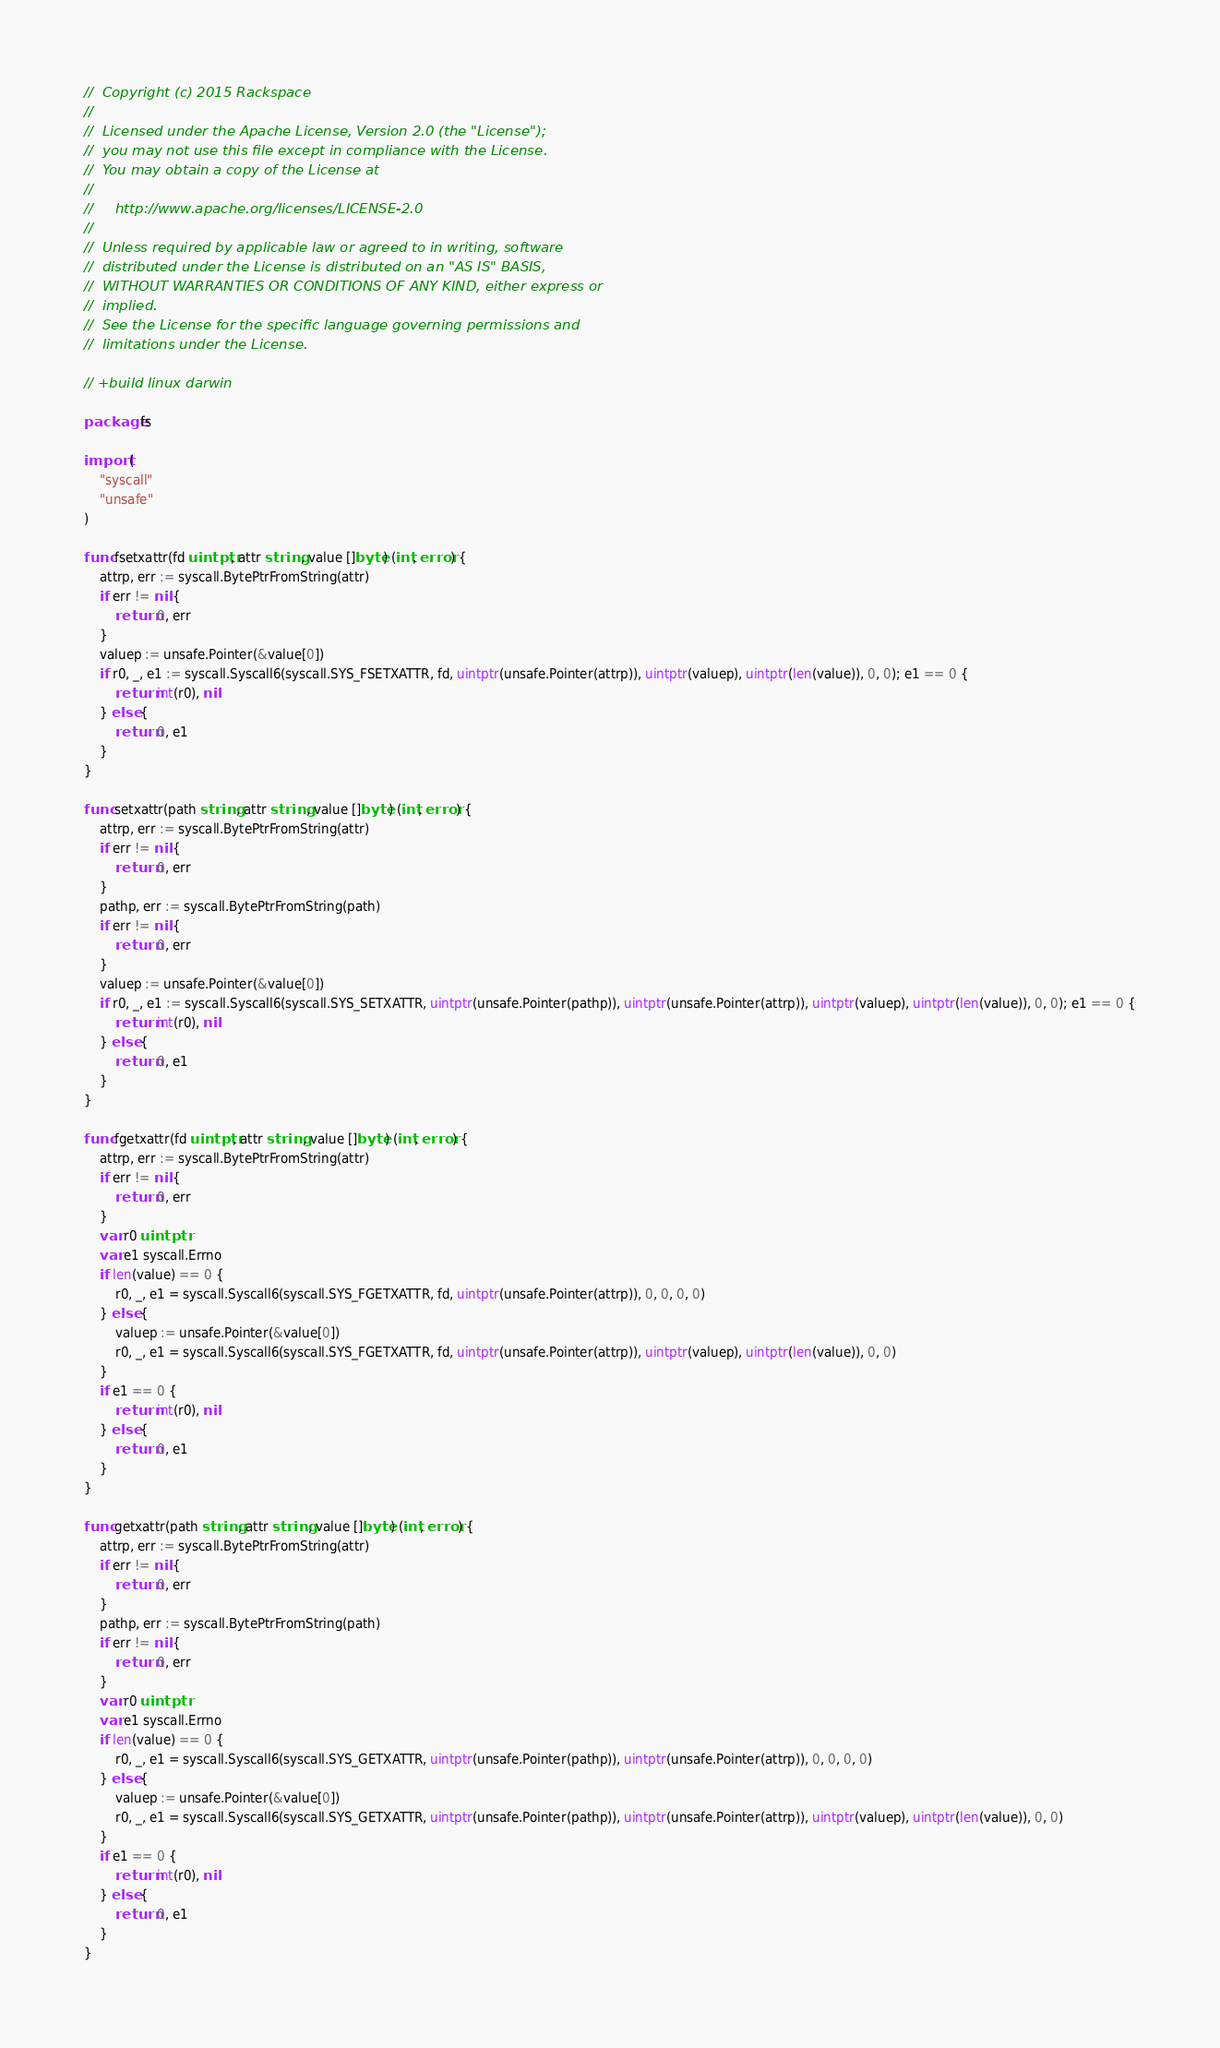Convert code to text. <code><loc_0><loc_0><loc_500><loc_500><_Go_>//  Copyright (c) 2015 Rackspace
//
//  Licensed under the Apache License, Version 2.0 (the "License");
//  you may not use this file except in compliance with the License.
//  You may obtain a copy of the License at
//
//     http://www.apache.org/licenses/LICENSE-2.0
//
//  Unless required by applicable law or agreed to in writing, software
//  distributed under the License is distributed on an "AS IS" BASIS,
//  WITHOUT WARRANTIES OR CONDITIONS OF ANY KIND, either express or
//  implied.
//  See the License for the specific language governing permissions and
//  limitations under the License.

// +build linux darwin

package fs

import (
	"syscall"
	"unsafe"
)

func fsetxattr(fd uintptr, attr string, value []byte) (int, error) {
	attrp, err := syscall.BytePtrFromString(attr)
	if err != nil {
		return 0, err
	}
	valuep := unsafe.Pointer(&value[0])
	if r0, _, e1 := syscall.Syscall6(syscall.SYS_FSETXATTR, fd, uintptr(unsafe.Pointer(attrp)), uintptr(valuep), uintptr(len(value)), 0, 0); e1 == 0 {
		return int(r0), nil
	} else {
		return 0, e1
	}
}

func setxattr(path string, attr string, value []byte) (int, error) {
	attrp, err := syscall.BytePtrFromString(attr)
	if err != nil {
		return 0, err
	}
	pathp, err := syscall.BytePtrFromString(path)
	if err != nil {
		return 0, err
	}
	valuep := unsafe.Pointer(&value[0])
	if r0, _, e1 := syscall.Syscall6(syscall.SYS_SETXATTR, uintptr(unsafe.Pointer(pathp)), uintptr(unsafe.Pointer(attrp)), uintptr(valuep), uintptr(len(value)), 0, 0); e1 == 0 {
		return int(r0), nil
	} else {
		return 0, e1
	}
}

func fgetxattr(fd uintptr, attr string, value []byte) (int, error) {
	attrp, err := syscall.BytePtrFromString(attr)
	if err != nil {
		return 0, err
	}
	var r0 uintptr
	var e1 syscall.Errno
	if len(value) == 0 {
		r0, _, e1 = syscall.Syscall6(syscall.SYS_FGETXATTR, fd, uintptr(unsafe.Pointer(attrp)), 0, 0, 0, 0)
	} else {
		valuep := unsafe.Pointer(&value[0])
		r0, _, e1 = syscall.Syscall6(syscall.SYS_FGETXATTR, fd, uintptr(unsafe.Pointer(attrp)), uintptr(valuep), uintptr(len(value)), 0, 0)
	}
	if e1 == 0 {
		return int(r0), nil
	} else {
		return 0, e1
	}
}

func getxattr(path string, attr string, value []byte) (int, error) {
	attrp, err := syscall.BytePtrFromString(attr)
	if err != nil {
		return 0, err
	}
	pathp, err := syscall.BytePtrFromString(path)
	if err != nil {
		return 0, err
	}
	var r0 uintptr
	var e1 syscall.Errno
	if len(value) == 0 {
		r0, _, e1 = syscall.Syscall6(syscall.SYS_GETXATTR, uintptr(unsafe.Pointer(pathp)), uintptr(unsafe.Pointer(attrp)), 0, 0, 0, 0)
	} else {
		valuep := unsafe.Pointer(&value[0])
		r0, _, e1 = syscall.Syscall6(syscall.SYS_GETXATTR, uintptr(unsafe.Pointer(pathp)), uintptr(unsafe.Pointer(attrp)), uintptr(valuep), uintptr(len(value)), 0, 0)
	}
	if e1 == 0 {
		return int(r0), nil
	} else {
		return 0, e1
	}
}
</code> 